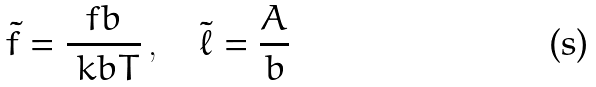Convert formula to latex. <formula><loc_0><loc_0><loc_500><loc_500>\tilde { f } = \frac { f b } { \ k b T } \, , \quad \tilde { \ell } = \frac { A } { b }</formula> 